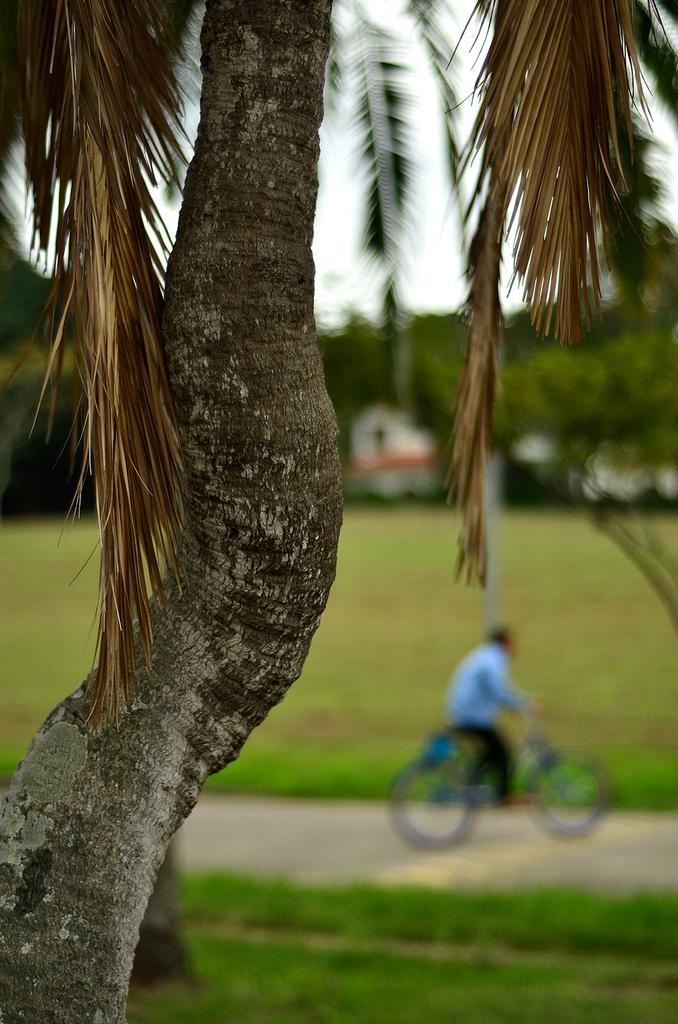In one or two sentences, can you explain what this image depicts? In this image there is a tree at the foreground of the image and at the background of the image there is a person riding bicycle. 